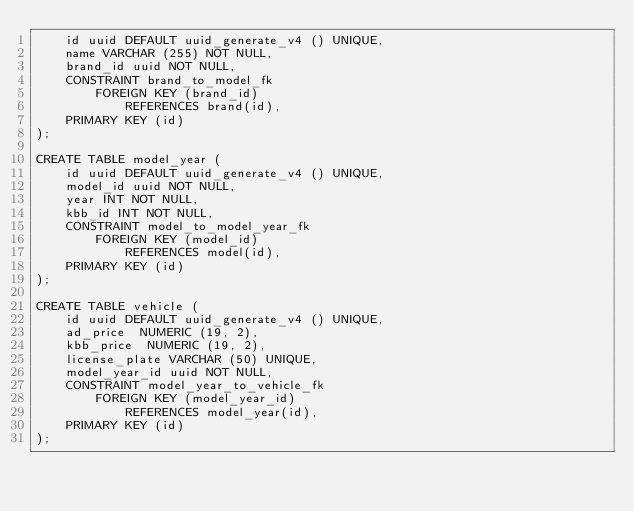<code> <loc_0><loc_0><loc_500><loc_500><_SQL_>    id uuid DEFAULT uuid_generate_v4 () UNIQUE,
    name VARCHAR (255) NOT NULL,
    brand_id uuid NOT NULL,
    CONSTRAINT brand_to_model_fk
        FOREIGN KEY (brand_id)
            REFERENCES brand(id),
    PRIMARY KEY (id)
);

CREATE TABLE model_year (
    id uuid DEFAULT uuid_generate_v4 () UNIQUE,
    model_id uuid NOT NULL,
    year INT NOT NULL,
    kbb_id INT NOT NULL,
    CONSTRAINT model_to_model_year_fk
        FOREIGN KEY (model_id)
            REFERENCES model(id),
    PRIMARY KEY (id)
);

CREATE TABLE vehicle (
    id uuid DEFAULT uuid_generate_v4 () UNIQUE,
    ad_price  NUMERIC (19, 2),
    kbb_price  NUMERIC (19, 2),
    license_plate VARCHAR (50) UNIQUE,
    model_year_id uuid NOT NULL,
    CONSTRAINT model_year_to_vehicle_fk
        FOREIGN KEY (model_year_id)
            REFERENCES model_year(id),
    PRIMARY KEY (id)
);
</code> 